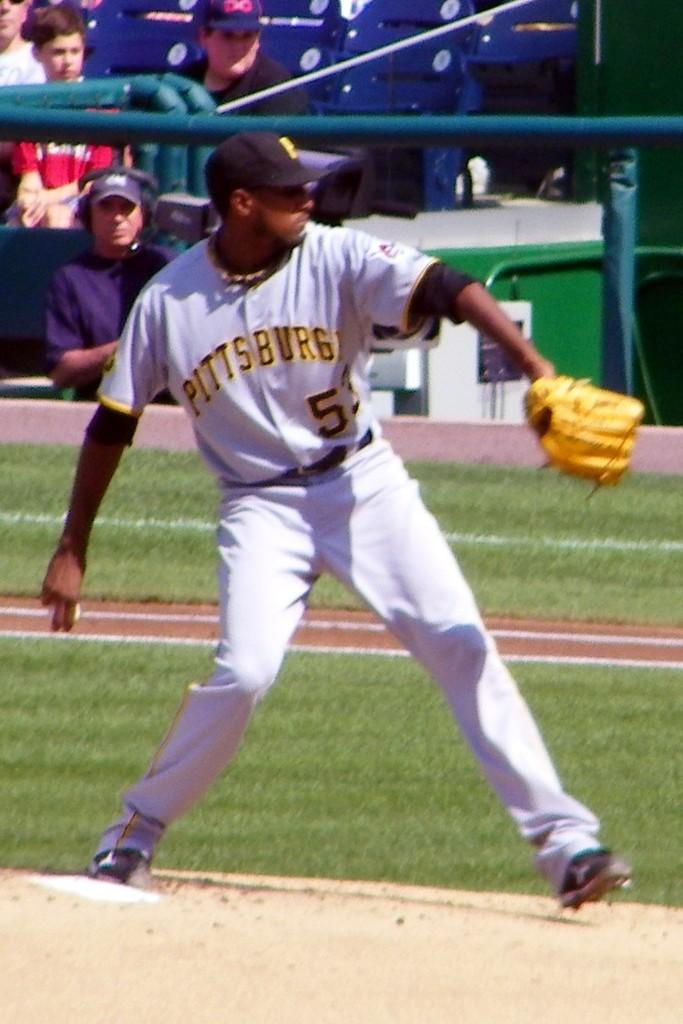<image>
Present a compact description of the photo's key features. A baseball player with a Pittsburgh jersey throwing a baseball. 